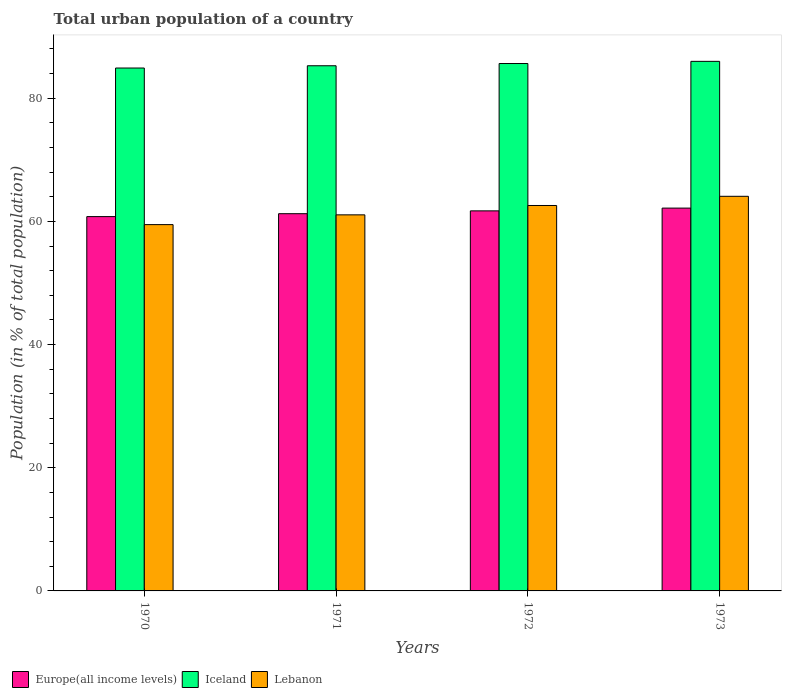How many different coloured bars are there?
Provide a succinct answer. 3. Are the number of bars per tick equal to the number of legend labels?
Your response must be concise. Yes. Are the number of bars on each tick of the X-axis equal?
Your answer should be very brief. Yes. In how many cases, is the number of bars for a given year not equal to the number of legend labels?
Provide a short and direct response. 0. What is the urban population in Lebanon in 1971?
Give a very brief answer. 61.06. Across all years, what is the maximum urban population in Lebanon?
Offer a very short reply. 64.07. Across all years, what is the minimum urban population in Europe(all income levels)?
Your response must be concise. 60.78. In which year was the urban population in Europe(all income levels) maximum?
Your response must be concise. 1973. What is the total urban population in Lebanon in the graph?
Your answer should be very brief. 247.19. What is the difference between the urban population in Iceland in 1971 and that in 1972?
Offer a very short reply. -0.36. What is the difference between the urban population in Europe(all income levels) in 1972 and the urban population in Iceland in 1971?
Make the answer very short. -23.56. What is the average urban population in Lebanon per year?
Offer a terse response. 61.8. In the year 1971, what is the difference between the urban population in Lebanon and urban population in Iceland?
Provide a short and direct response. -24.21. In how many years, is the urban population in Europe(all income levels) greater than 64 %?
Provide a short and direct response. 0. What is the ratio of the urban population in Europe(all income levels) in 1972 to that in 1973?
Ensure brevity in your answer.  0.99. Is the urban population in Lebanon in 1972 less than that in 1973?
Ensure brevity in your answer.  Yes. Is the difference between the urban population in Lebanon in 1971 and 1972 greater than the difference between the urban population in Iceland in 1971 and 1972?
Make the answer very short. No. What is the difference between the highest and the second highest urban population in Iceland?
Your answer should be very brief. 0.35. What is the difference between the highest and the lowest urban population in Lebanon?
Your response must be concise. 4.6. In how many years, is the urban population in Lebanon greater than the average urban population in Lebanon taken over all years?
Keep it short and to the point. 2. What does the 3rd bar from the left in 1972 represents?
Give a very brief answer. Lebanon. What does the 1st bar from the right in 1971 represents?
Provide a succinct answer. Lebanon. Is it the case that in every year, the sum of the urban population in Iceland and urban population in Europe(all income levels) is greater than the urban population in Lebanon?
Your answer should be compact. Yes. Does the graph contain any zero values?
Offer a terse response. No. Where does the legend appear in the graph?
Your answer should be very brief. Bottom left. How many legend labels are there?
Give a very brief answer. 3. What is the title of the graph?
Your response must be concise. Total urban population of a country. Does "Papua New Guinea" appear as one of the legend labels in the graph?
Provide a succinct answer. No. What is the label or title of the X-axis?
Your answer should be very brief. Years. What is the label or title of the Y-axis?
Provide a succinct answer. Population (in % of total population). What is the Population (in % of total population) in Europe(all income levels) in 1970?
Your answer should be compact. 60.78. What is the Population (in % of total population) of Iceland in 1970?
Offer a terse response. 84.9. What is the Population (in % of total population) in Lebanon in 1970?
Provide a succinct answer. 59.48. What is the Population (in % of total population) in Europe(all income levels) in 1971?
Provide a succinct answer. 61.25. What is the Population (in % of total population) of Iceland in 1971?
Your answer should be very brief. 85.27. What is the Population (in % of total population) in Lebanon in 1971?
Provide a short and direct response. 61.06. What is the Population (in % of total population) in Europe(all income levels) in 1972?
Give a very brief answer. 61.71. What is the Population (in % of total population) in Iceland in 1972?
Offer a terse response. 85.63. What is the Population (in % of total population) of Lebanon in 1972?
Ensure brevity in your answer.  62.58. What is the Population (in % of total population) in Europe(all income levels) in 1973?
Keep it short and to the point. 62.16. What is the Population (in % of total population) in Iceland in 1973?
Offer a terse response. 85.98. What is the Population (in % of total population) in Lebanon in 1973?
Provide a succinct answer. 64.07. Across all years, what is the maximum Population (in % of total population) in Europe(all income levels)?
Offer a very short reply. 62.16. Across all years, what is the maximum Population (in % of total population) of Iceland?
Your answer should be very brief. 85.98. Across all years, what is the maximum Population (in % of total population) of Lebanon?
Give a very brief answer. 64.07. Across all years, what is the minimum Population (in % of total population) of Europe(all income levels)?
Give a very brief answer. 60.78. Across all years, what is the minimum Population (in % of total population) of Iceland?
Provide a succinct answer. 84.9. Across all years, what is the minimum Population (in % of total population) in Lebanon?
Your response must be concise. 59.48. What is the total Population (in % of total population) in Europe(all income levels) in the graph?
Give a very brief answer. 245.89. What is the total Population (in % of total population) in Iceland in the graph?
Your answer should be very brief. 341.78. What is the total Population (in % of total population) in Lebanon in the graph?
Give a very brief answer. 247.19. What is the difference between the Population (in % of total population) of Europe(all income levels) in 1970 and that in 1971?
Your response must be concise. -0.47. What is the difference between the Population (in % of total population) in Iceland in 1970 and that in 1971?
Give a very brief answer. -0.37. What is the difference between the Population (in % of total population) of Lebanon in 1970 and that in 1971?
Keep it short and to the point. -1.58. What is the difference between the Population (in % of total population) of Europe(all income levels) in 1970 and that in 1972?
Provide a short and direct response. -0.93. What is the difference between the Population (in % of total population) in Iceland in 1970 and that in 1972?
Provide a succinct answer. -0.73. What is the difference between the Population (in % of total population) in Lebanon in 1970 and that in 1972?
Offer a terse response. -3.1. What is the difference between the Population (in % of total population) of Europe(all income levels) in 1970 and that in 1973?
Your answer should be compact. -1.38. What is the difference between the Population (in % of total population) of Iceland in 1970 and that in 1973?
Make the answer very short. -1.08. What is the difference between the Population (in % of total population) of Lebanon in 1970 and that in 1973?
Offer a terse response. -4.6. What is the difference between the Population (in % of total population) in Europe(all income levels) in 1971 and that in 1972?
Give a very brief answer. -0.46. What is the difference between the Population (in % of total population) in Iceland in 1971 and that in 1972?
Make the answer very short. -0.36. What is the difference between the Population (in % of total population) of Lebanon in 1971 and that in 1972?
Offer a very short reply. -1.52. What is the difference between the Population (in % of total population) of Europe(all income levels) in 1971 and that in 1973?
Offer a very short reply. -0.91. What is the difference between the Population (in % of total population) of Iceland in 1971 and that in 1973?
Your response must be concise. -0.71. What is the difference between the Population (in % of total population) in Lebanon in 1971 and that in 1973?
Ensure brevity in your answer.  -3.01. What is the difference between the Population (in % of total population) of Europe(all income levels) in 1972 and that in 1973?
Your answer should be very brief. -0.45. What is the difference between the Population (in % of total population) of Iceland in 1972 and that in 1973?
Make the answer very short. -0.35. What is the difference between the Population (in % of total population) in Lebanon in 1972 and that in 1973?
Keep it short and to the point. -1.49. What is the difference between the Population (in % of total population) in Europe(all income levels) in 1970 and the Population (in % of total population) in Iceland in 1971?
Provide a short and direct response. -24.49. What is the difference between the Population (in % of total population) in Europe(all income levels) in 1970 and the Population (in % of total population) in Lebanon in 1971?
Make the answer very short. -0.28. What is the difference between the Population (in % of total population) in Iceland in 1970 and the Population (in % of total population) in Lebanon in 1971?
Give a very brief answer. 23.84. What is the difference between the Population (in % of total population) in Europe(all income levels) in 1970 and the Population (in % of total population) in Iceland in 1972?
Provide a short and direct response. -24.85. What is the difference between the Population (in % of total population) in Europe(all income levels) in 1970 and the Population (in % of total population) in Lebanon in 1972?
Keep it short and to the point. -1.8. What is the difference between the Population (in % of total population) in Iceland in 1970 and the Population (in % of total population) in Lebanon in 1972?
Your answer should be very brief. 22.32. What is the difference between the Population (in % of total population) of Europe(all income levels) in 1970 and the Population (in % of total population) of Iceland in 1973?
Keep it short and to the point. -25.21. What is the difference between the Population (in % of total population) of Europe(all income levels) in 1970 and the Population (in % of total population) of Lebanon in 1973?
Provide a succinct answer. -3.3. What is the difference between the Population (in % of total population) of Iceland in 1970 and the Population (in % of total population) of Lebanon in 1973?
Your response must be concise. 20.83. What is the difference between the Population (in % of total population) in Europe(all income levels) in 1971 and the Population (in % of total population) in Iceland in 1972?
Keep it short and to the point. -24.38. What is the difference between the Population (in % of total population) in Europe(all income levels) in 1971 and the Population (in % of total population) in Lebanon in 1972?
Give a very brief answer. -1.33. What is the difference between the Population (in % of total population) in Iceland in 1971 and the Population (in % of total population) in Lebanon in 1972?
Offer a terse response. 22.69. What is the difference between the Population (in % of total population) in Europe(all income levels) in 1971 and the Population (in % of total population) in Iceland in 1973?
Ensure brevity in your answer.  -24.74. What is the difference between the Population (in % of total population) in Europe(all income levels) in 1971 and the Population (in % of total population) in Lebanon in 1973?
Your response must be concise. -2.82. What is the difference between the Population (in % of total population) of Iceland in 1971 and the Population (in % of total population) of Lebanon in 1973?
Make the answer very short. 21.2. What is the difference between the Population (in % of total population) of Europe(all income levels) in 1972 and the Population (in % of total population) of Iceland in 1973?
Give a very brief answer. -24.28. What is the difference between the Population (in % of total population) of Europe(all income levels) in 1972 and the Population (in % of total population) of Lebanon in 1973?
Provide a succinct answer. -2.36. What is the difference between the Population (in % of total population) in Iceland in 1972 and the Population (in % of total population) in Lebanon in 1973?
Your response must be concise. 21.56. What is the average Population (in % of total population) in Europe(all income levels) per year?
Make the answer very short. 61.47. What is the average Population (in % of total population) in Iceland per year?
Your answer should be very brief. 85.45. What is the average Population (in % of total population) in Lebanon per year?
Your response must be concise. 61.8. In the year 1970, what is the difference between the Population (in % of total population) in Europe(all income levels) and Population (in % of total population) in Iceland?
Your answer should be compact. -24.12. In the year 1970, what is the difference between the Population (in % of total population) in Europe(all income levels) and Population (in % of total population) in Lebanon?
Offer a terse response. 1.3. In the year 1970, what is the difference between the Population (in % of total population) in Iceland and Population (in % of total population) in Lebanon?
Ensure brevity in your answer.  25.43. In the year 1971, what is the difference between the Population (in % of total population) of Europe(all income levels) and Population (in % of total population) of Iceland?
Your answer should be compact. -24.02. In the year 1971, what is the difference between the Population (in % of total population) of Europe(all income levels) and Population (in % of total population) of Lebanon?
Offer a terse response. 0.19. In the year 1971, what is the difference between the Population (in % of total population) of Iceland and Population (in % of total population) of Lebanon?
Give a very brief answer. 24.21. In the year 1972, what is the difference between the Population (in % of total population) in Europe(all income levels) and Population (in % of total population) in Iceland?
Your answer should be very brief. -23.92. In the year 1972, what is the difference between the Population (in % of total population) of Europe(all income levels) and Population (in % of total population) of Lebanon?
Give a very brief answer. -0.87. In the year 1972, what is the difference between the Population (in % of total population) of Iceland and Population (in % of total population) of Lebanon?
Your response must be concise. 23.05. In the year 1973, what is the difference between the Population (in % of total population) in Europe(all income levels) and Population (in % of total population) in Iceland?
Provide a short and direct response. -23.83. In the year 1973, what is the difference between the Population (in % of total population) of Europe(all income levels) and Population (in % of total population) of Lebanon?
Provide a short and direct response. -1.92. In the year 1973, what is the difference between the Population (in % of total population) of Iceland and Population (in % of total population) of Lebanon?
Your response must be concise. 21.91. What is the ratio of the Population (in % of total population) of Europe(all income levels) in 1970 to that in 1971?
Offer a terse response. 0.99. What is the ratio of the Population (in % of total population) in Lebanon in 1970 to that in 1971?
Give a very brief answer. 0.97. What is the ratio of the Population (in % of total population) of Europe(all income levels) in 1970 to that in 1972?
Offer a very short reply. 0.98. What is the ratio of the Population (in % of total population) of Lebanon in 1970 to that in 1972?
Offer a terse response. 0.95. What is the ratio of the Population (in % of total population) of Europe(all income levels) in 1970 to that in 1973?
Your response must be concise. 0.98. What is the ratio of the Population (in % of total population) in Iceland in 1970 to that in 1973?
Offer a very short reply. 0.99. What is the ratio of the Population (in % of total population) in Lebanon in 1970 to that in 1973?
Offer a very short reply. 0.93. What is the ratio of the Population (in % of total population) of Europe(all income levels) in 1971 to that in 1972?
Ensure brevity in your answer.  0.99. What is the ratio of the Population (in % of total population) in Lebanon in 1971 to that in 1972?
Make the answer very short. 0.98. What is the ratio of the Population (in % of total population) of Europe(all income levels) in 1971 to that in 1973?
Keep it short and to the point. 0.99. What is the ratio of the Population (in % of total population) of Iceland in 1971 to that in 1973?
Provide a short and direct response. 0.99. What is the ratio of the Population (in % of total population) in Lebanon in 1971 to that in 1973?
Keep it short and to the point. 0.95. What is the ratio of the Population (in % of total population) of Iceland in 1972 to that in 1973?
Your response must be concise. 1. What is the ratio of the Population (in % of total population) of Lebanon in 1972 to that in 1973?
Offer a very short reply. 0.98. What is the difference between the highest and the second highest Population (in % of total population) in Europe(all income levels)?
Ensure brevity in your answer.  0.45. What is the difference between the highest and the second highest Population (in % of total population) of Iceland?
Make the answer very short. 0.35. What is the difference between the highest and the second highest Population (in % of total population) in Lebanon?
Provide a short and direct response. 1.49. What is the difference between the highest and the lowest Population (in % of total population) of Europe(all income levels)?
Give a very brief answer. 1.38. What is the difference between the highest and the lowest Population (in % of total population) in Iceland?
Your answer should be compact. 1.08. What is the difference between the highest and the lowest Population (in % of total population) in Lebanon?
Offer a terse response. 4.6. 